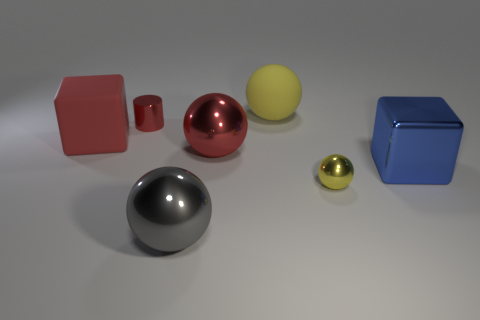Are there fewer large red matte cubes behind the red ball than tiny red spheres?
Make the answer very short. No. There is another big ball that is the same material as the big gray ball; what color is it?
Your response must be concise. Red. What is the size of the gray metallic ball on the left side of the large rubber sphere?
Offer a terse response. Large. Does the tiny red cylinder have the same material as the large blue object?
Make the answer very short. Yes. Are there any red matte objects to the right of the small metal object that is behind the yellow thing in front of the red shiny sphere?
Ensure brevity in your answer.  No. The tiny metallic sphere has what color?
Ensure brevity in your answer.  Yellow. There is a rubber sphere that is the same size as the blue object; what color is it?
Provide a succinct answer. Yellow. There is a red metal object that is in front of the tiny red shiny object; is its shape the same as the blue metallic thing?
Keep it short and to the point. No. What color is the metal sphere that is behind the cube that is in front of the big block on the left side of the large yellow ball?
Provide a succinct answer. Red. Are any tiny yellow shiny balls visible?
Ensure brevity in your answer.  Yes. 